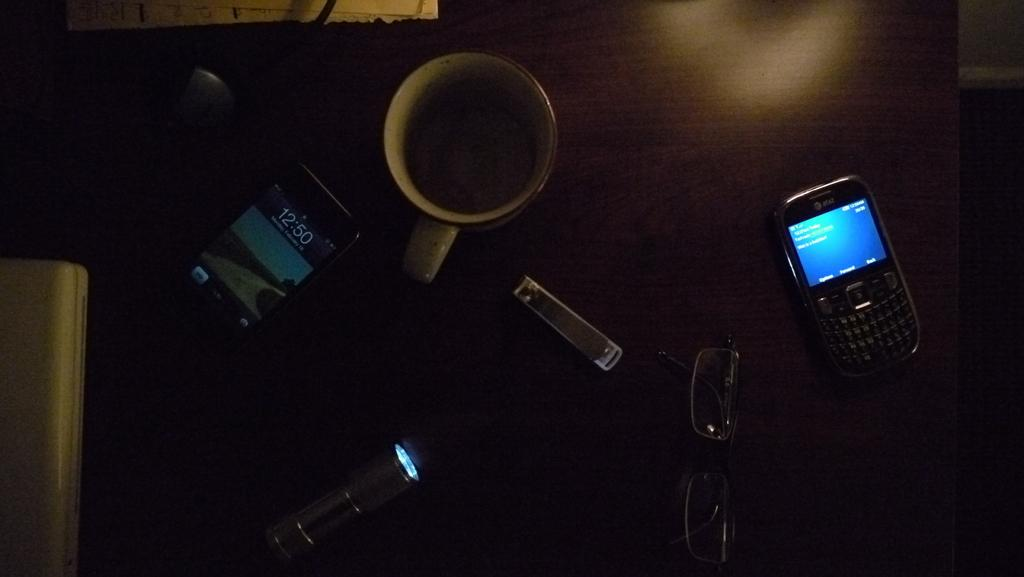What is the main object in the image? There is a box in the image. What other items can be seen on the table in the image? There are cell phones, a torch, a cup, spectacles, and a nail clipper in the image. Can you describe the location of these objects? All these objects are placed on a table in the image. How does the spy use the notebook to communicate with the wave in the image? There is no notebook, wave, or spy present in the image. 